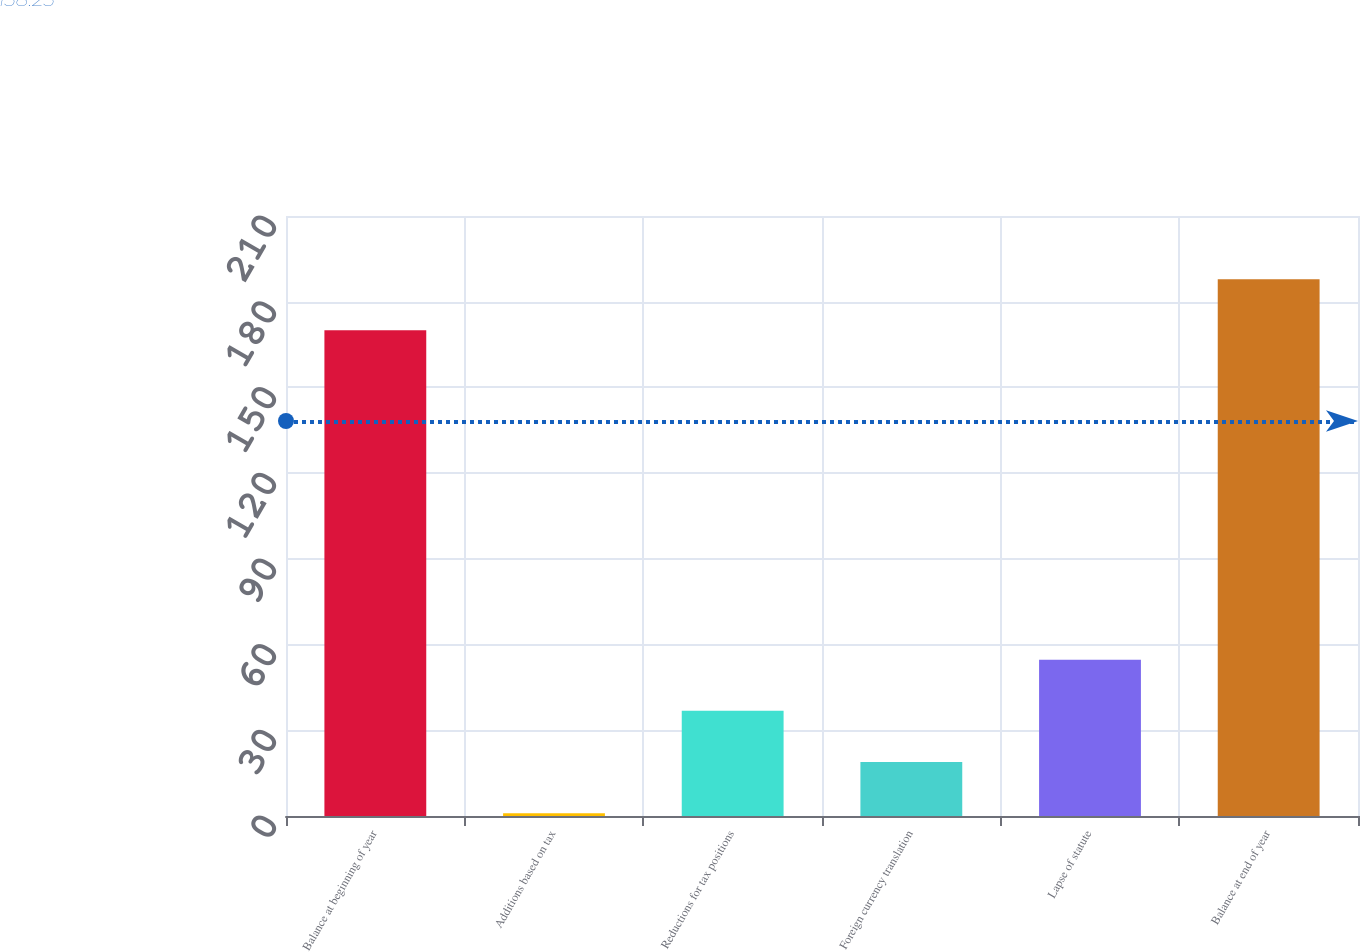Convert chart to OTSL. <chart><loc_0><loc_0><loc_500><loc_500><bar_chart><fcel>Balance at beginning of year<fcel>Additions based on tax<fcel>Reductions for tax positions<fcel>Foreign currency translation<fcel>Lapse of statute<fcel>Balance at end of year<nl><fcel>170<fcel>1<fcel>36.8<fcel>18.9<fcel>54.7<fcel>187.9<nl></chart> 